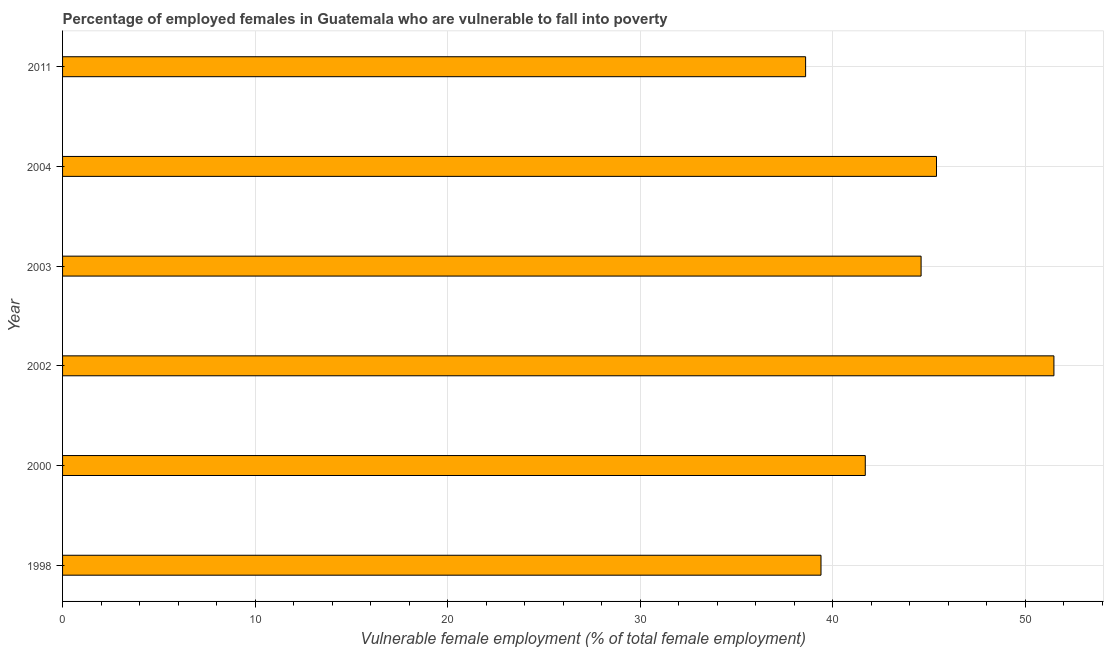Does the graph contain any zero values?
Make the answer very short. No. What is the title of the graph?
Provide a short and direct response. Percentage of employed females in Guatemala who are vulnerable to fall into poverty. What is the label or title of the X-axis?
Give a very brief answer. Vulnerable female employment (% of total female employment). What is the percentage of employed females who are vulnerable to fall into poverty in 2000?
Provide a short and direct response. 41.7. Across all years, what is the maximum percentage of employed females who are vulnerable to fall into poverty?
Ensure brevity in your answer.  51.5. Across all years, what is the minimum percentage of employed females who are vulnerable to fall into poverty?
Ensure brevity in your answer.  38.6. In which year was the percentage of employed females who are vulnerable to fall into poverty maximum?
Offer a very short reply. 2002. In which year was the percentage of employed females who are vulnerable to fall into poverty minimum?
Give a very brief answer. 2011. What is the sum of the percentage of employed females who are vulnerable to fall into poverty?
Your answer should be compact. 261.2. What is the difference between the percentage of employed females who are vulnerable to fall into poverty in 1998 and 2000?
Make the answer very short. -2.3. What is the average percentage of employed females who are vulnerable to fall into poverty per year?
Offer a terse response. 43.53. What is the median percentage of employed females who are vulnerable to fall into poverty?
Provide a short and direct response. 43.15. Do a majority of the years between 2000 and 2011 (inclusive) have percentage of employed females who are vulnerable to fall into poverty greater than 10 %?
Your response must be concise. Yes. What is the ratio of the percentage of employed females who are vulnerable to fall into poverty in 2000 to that in 2004?
Your answer should be compact. 0.92. What is the difference between two consecutive major ticks on the X-axis?
Ensure brevity in your answer.  10. Are the values on the major ticks of X-axis written in scientific E-notation?
Make the answer very short. No. What is the Vulnerable female employment (% of total female employment) of 1998?
Provide a succinct answer. 39.4. What is the Vulnerable female employment (% of total female employment) of 2000?
Give a very brief answer. 41.7. What is the Vulnerable female employment (% of total female employment) in 2002?
Offer a very short reply. 51.5. What is the Vulnerable female employment (% of total female employment) of 2003?
Keep it short and to the point. 44.6. What is the Vulnerable female employment (% of total female employment) of 2004?
Give a very brief answer. 45.4. What is the Vulnerable female employment (% of total female employment) of 2011?
Provide a short and direct response. 38.6. What is the difference between the Vulnerable female employment (% of total female employment) in 1998 and 2002?
Your answer should be very brief. -12.1. What is the difference between the Vulnerable female employment (% of total female employment) in 1998 and 2004?
Your response must be concise. -6. What is the difference between the Vulnerable female employment (% of total female employment) in 2000 and 2002?
Keep it short and to the point. -9.8. What is the difference between the Vulnerable female employment (% of total female employment) in 2000 and 2003?
Your answer should be compact. -2.9. What is the difference between the Vulnerable female employment (% of total female employment) in 2000 and 2004?
Make the answer very short. -3.7. What is the difference between the Vulnerable female employment (% of total female employment) in 2000 and 2011?
Offer a terse response. 3.1. What is the difference between the Vulnerable female employment (% of total female employment) in 2002 and 2004?
Give a very brief answer. 6.1. What is the difference between the Vulnerable female employment (% of total female employment) in 2003 and 2011?
Your answer should be compact. 6. What is the difference between the Vulnerable female employment (% of total female employment) in 2004 and 2011?
Give a very brief answer. 6.8. What is the ratio of the Vulnerable female employment (% of total female employment) in 1998 to that in 2000?
Provide a succinct answer. 0.94. What is the ratio of the Vulnerable female employment (% of total female employment) in 1998 to that in 2002?
Ensure brevity in your answer.  0.77. What is the ratio of the Vulnerable female employment (% of total female employment) in 1998 to that in 2003?
Your response must be concise. 0.88. What is the ratio of the Vulnerable female employment (% of total female employment) in 1998 to that in 2004?
Your answer should be very brief. 0.87. What is the ratio of the Vulnerable female employment (% of total female employment) in 1998 to that in 2011?
Your answer should be very brief. 1.02. What is the ratio of the Vulnerable female employment (% of total female employment) in 2000 to that in 2002?
Offer a terse response. 0.81. What is the ratio of the Vulnerable female employment (% of total female employment) in 2000 to that in 2003?
Your response must be concise. 0.94. What is the ratio of the Vulnerable female employment (% of total female employment) in 2000 to that in 2004?
Give a very brief answer. 0.92. What is the ratio of the Vulnerable female employment (% of total female employment) in 2002 to that in 2003?
Offer a terse response. 1.16. What is the ratio of the Vulnerable female employment (% of total female employment) in 2002 to that in 2004?
Keep it short and to the point. 1.13. What is the ratio of the Vulnerable female employment (% of total female employment) in 2002 to that in 2011?
Ensure brevity in your answer.  1.33. What is the ratio of the Vulnerable female employment (% of total female employment) in 2003 to that in 2004?
Your response must be concise. 0.98. What is the ratio of the Vulnerable female employment (% of total female employment) in 2003 to that in 2011?
Make the answer very short. 1.16. What is the ratio of the Vulnerable female employment (% of total female employment) in 2004 to that in 2011?
Provide a succinct answer. 1.18. 